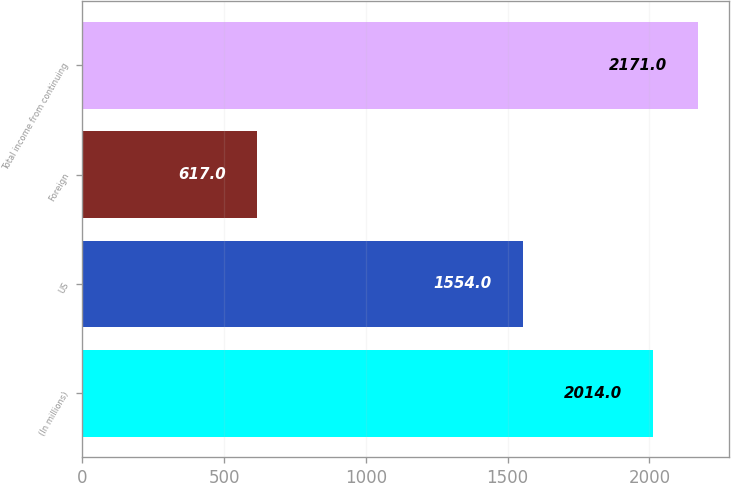Convert chart. <chart><loc_0><loc_0><loc_500><loc_500><bar_chart><fcel>(In millions)<fcel>US<fcel>Foreign<fcel>Total income from continuing<nl><fcel>2014<fcel>1554<fcel>617<fcel>2171<nl></chart> 